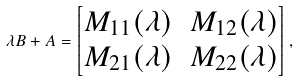<formula> <loc_0><loc_0><loc_500><loc_500>\lambda B + A = \begin{bmatrix} M _ { 1 1 } ( \lambda ) & M _ { 1 2 } ( \lambda ) \\ M _ { 2 1 } ( \lambda ) & M _ { 2 2 } ( \lambda ) \end{bmatrix} ,</formula> 